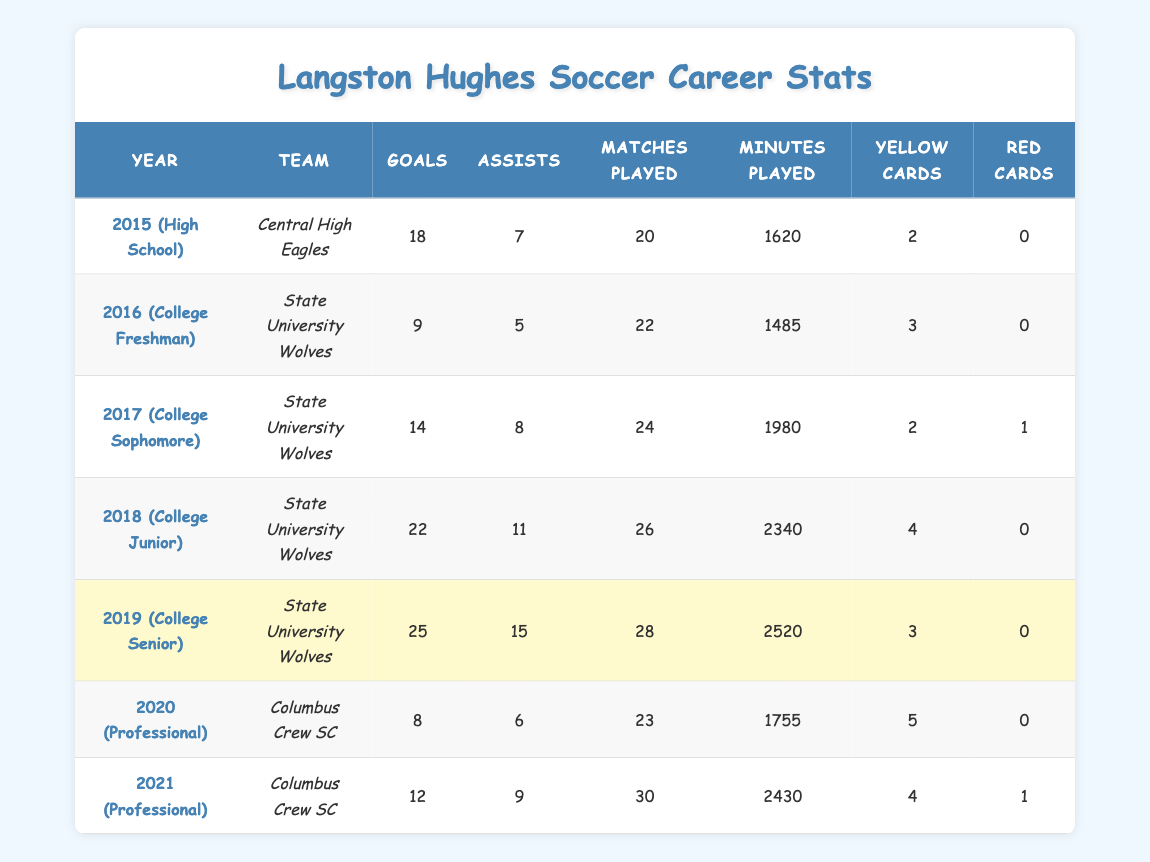What year did Langston score the highest number of goals? By looking at the table, we can see that in 2019, Langston scored 25 goals, which is the highest compared to other seasons.
Answer: 2019 How many assists did Langston achieve during his college freshman year? From the 2016 entry in the table, Langston provided 5 assists while playing for State University Wolves.
Answer: 5 In which season did Langston play the most matches? By examining the "Matches Played" column, we see that he played 30 matches during the 2021 professional season with Columbus Crew SC.
Answer: 2021 What is the total number of goals scored by Langston during his college years (2016-2019)? We add the goals from each college season: 9 (2016) + 14 (2017) + 22 (2018) + 25 (2019) = 70.
Answer: 70 Did Langston receive more yellow cards in 2020 than in 2015? In 2020, he received 5 yellow cards, while in 2015, he received only 2 yellow cards. Since 5 is greater than 2, the statement is true.
Answer: Yes What was Langston's total minutes played across his entire college career? The minutes played during the college years are: 1485 (2016) + 1980 (2017) + 2340 (2018) + 2520 (2019) = 10325 total minutes across those 4 seasons.
Answer: 10325 In which season did Langston receive the most red cards? The only season he received a red card was in 2017 during his sophomore year, where he received 1 red card. No other seasons recorded any red cards.
Answer: 2017 How many assists did Langston achieve during his professional career in total? We sum the assists from both professional seasons: 6 (2020) + 9 (2021) = 15 total assists during his professional career.
Answer: 15 What is the average number of goals scored per match for Langston in his senior college year? In the 2019 season, Langston scored 25 goals over 28 matches. The average is calculated as 25/28 = approximately 0.89 goals per match.
Answer: 0.89 